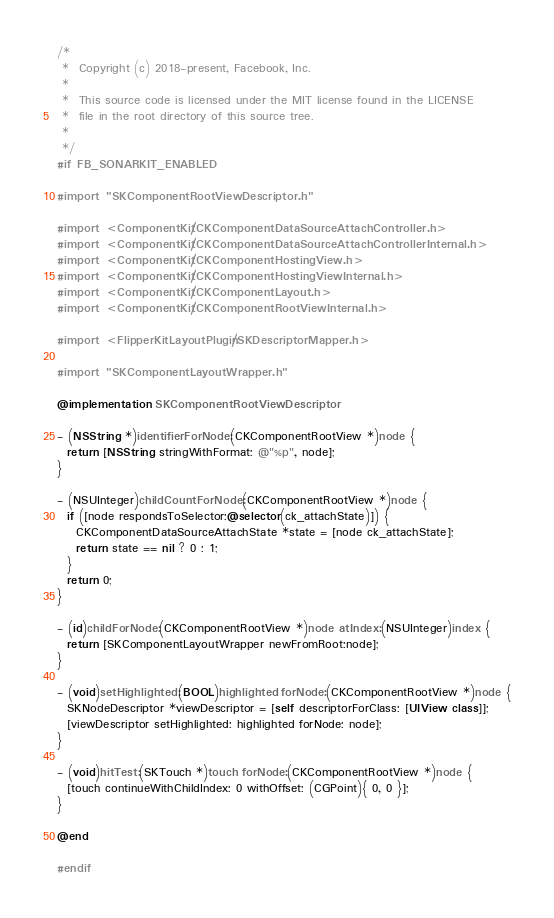Convert code to text. <code><loc_0><loc_0><loc_500><loc_500><_ObjectiveC_>/*
 *  Copyright (c) 2018-present, Facebook, Inc.
 *
 *  This source code is licensed under the MIT license found in the LICENSE
 *  file in the root directory of this source tree.
 *
 */
#if FB_SONARKIT_ENABLED

#import "SKComponentRootViewDescriptor.h"

#import <ComponentKit/CKComponentDataSourceAttachController.h>
#import <ComponentKit/CKComponentDataSourceAttachControllerInternal.h>
#import <ComponentKit/CKComponentHostingView.h>
#import <ComponentKit/CKComponentHostingViewInternal.h>
#import <ComponentKit/CKComponentLayout.h>
#import <ComponentKit/CKComponentRootViewInternal.h>

#import <FlipperKitLayoutPlugin/SKDescriptorMapper.h>

#import "SKComponentLayoutWrapper.h"

@implementation SKComponentRootViewDescriptor

- (NSString *)identifierForNode:(CKComponentRootView *)node {
  return [NSString stringWithFormat: @"%p", node];
}

- (NSUInteger)childCountForNode:(CKComponentRootView *)node {
  if ([node respondsToSelector:@selector(ck_attachState)]) {
    CKComponentDataSourceAttachState *state = [node ck_attachState];
    return state == nil ? 0 : 1;
  }
  return 0;
}

- (id)childForNode:(CKComponentRootView *)node atIndex:(NSUInteger)index {
  return [SKComponentLayoutWrapper newFromRoot:node];
}

- (void)setHighlighted:(BOOL)highlighted forNode:(CKComponentRootView *)node {
  SKNodeDescriptor *viewDescriptor = [self descriptorForClass: [UIView class]];
  [viewDescriptor setHighlighted: highlighted forNode: node];
}

- (void)hitTest:(SKTouch *)touch forNode:(CKComponentRootView *)node {
  [touch continueWithChildIndex: 0 withOffset: (CGPoint){ 0, 0 }];
}

@end

#endif
</code> 